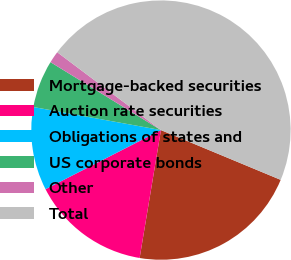Convert chart to OTSL. <chart><loc_0><loc_0><loc_500><loc_500><pie_chart><fcel>Mortgage-backed securities<fcel>Auction rate securities<fcel>Obligations of states and<fcel>US corporate bonds<fcel>Other<fcel>Total<nl><fcel>21.36%<fcel>14.84%<fcel>10.38%<fcel>5.93%<fcel>1.47%<fcel>46.02%<nl></chart> 